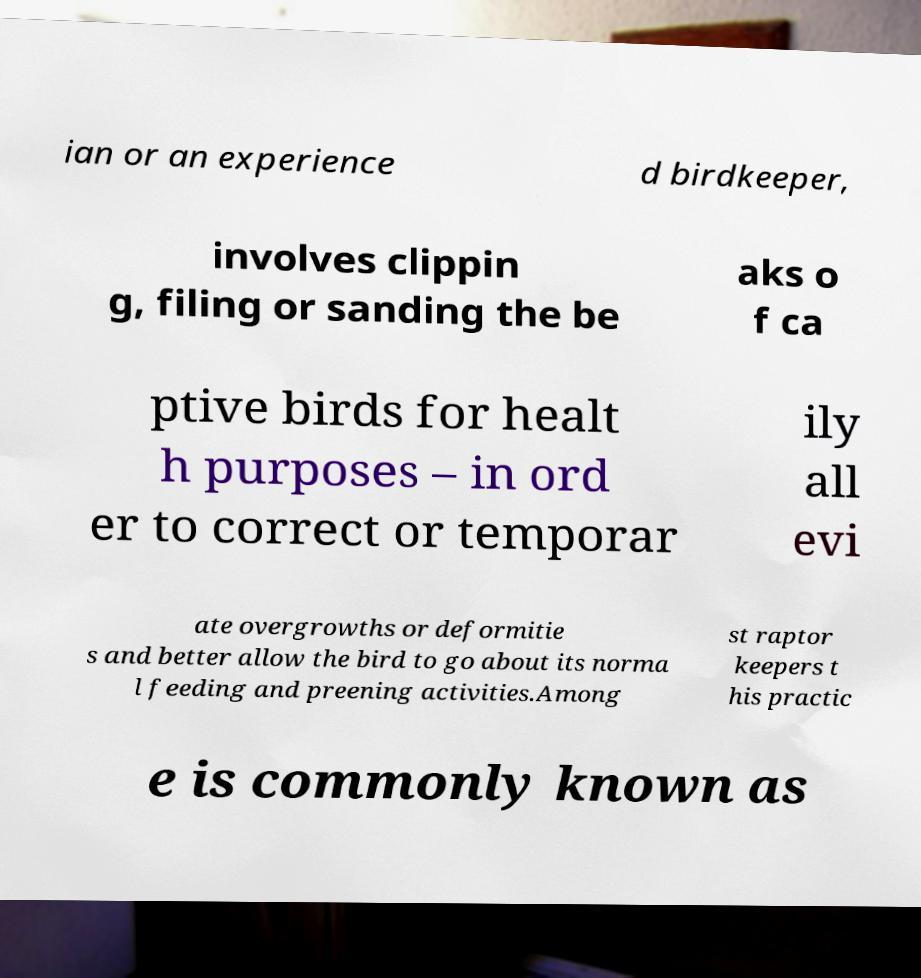Could you assist in decoding the text presented in this image and type it out clearly? ian or an experience d birdkeeper, involves clippin g, filing or sanding the be aks o f ca ptive birds for healt h purposes – in ord er to correct or temporar ily all evi ate overgrowths or deformitie s and better allow the bird to go about its norma l feeding and preening activities.Among st raptor keepers t his practic e is commonly known as 